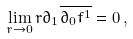<formula> <loc_0><loc_0><loc_500><loc_500>\lim _ { r \rightarrow 0 } r \partial _ { 1 } \overline { \partial _ { 0 } f ^ { 1 } } = 0 \, ,</formula> 